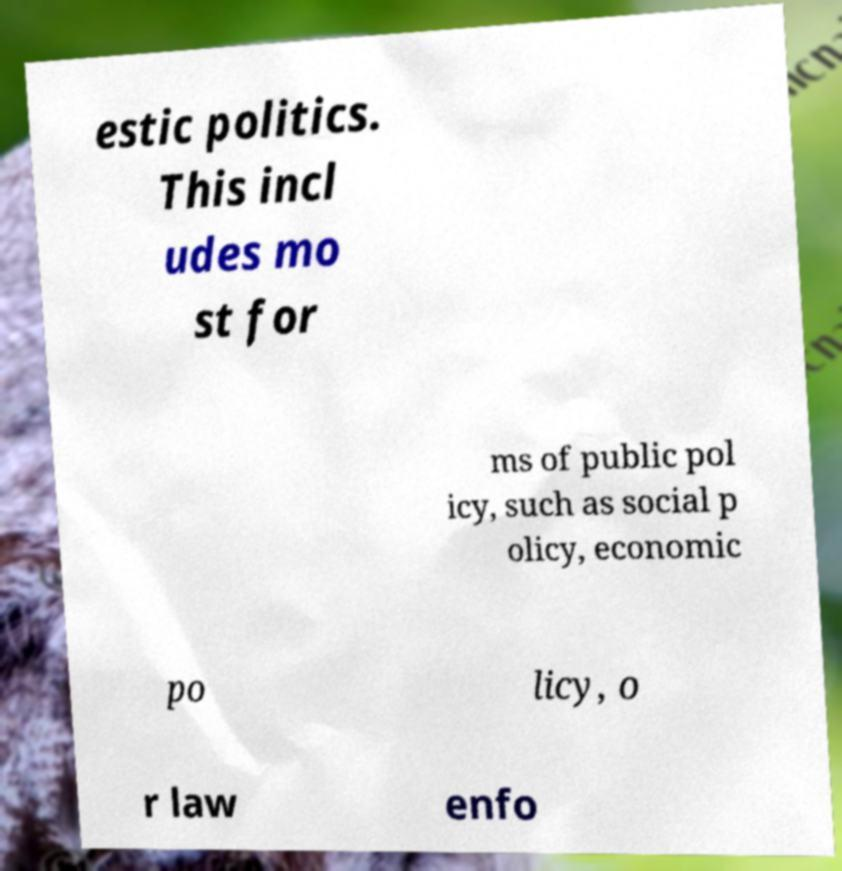There's text embedded in this image that I need extracted. Can you transcribe it verbatim? estic politics. This incl udes mo st for ms of public pol icy, such as social p olicy, economic po licy, o r law enfo 